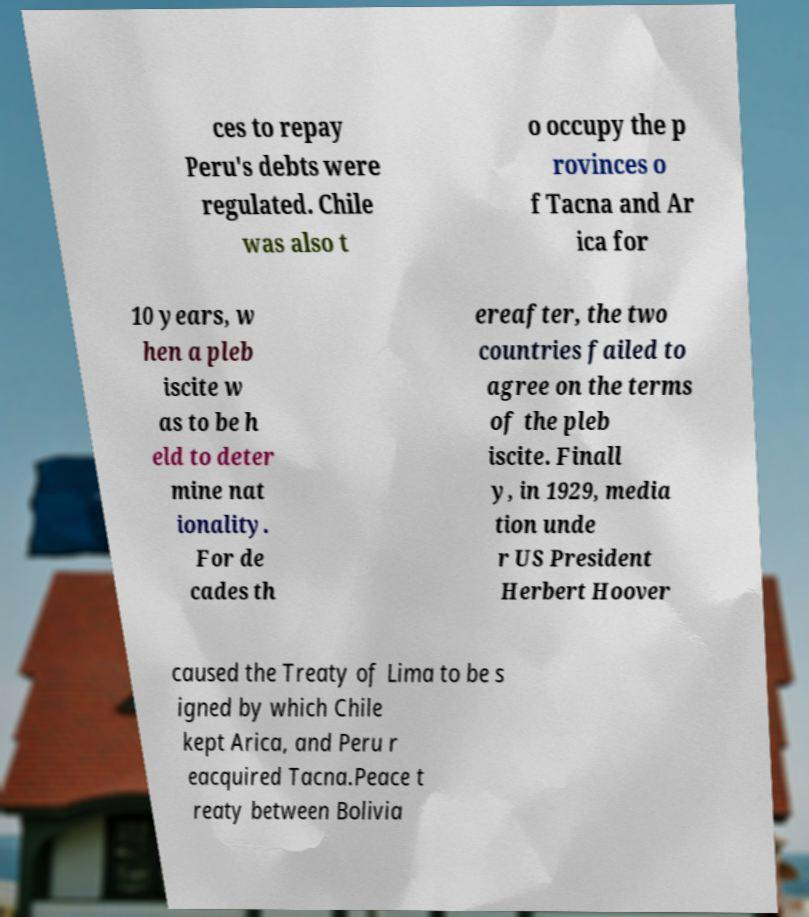Can you read and provide the text displayed in the image?This photo seems to have some interesting text. Can you extract and type it out for me? ces to repay Peru's debts were regulated. Chile was also t o occupy the p rovinces o f Tacna and Ar ica for 10 years, w hen a pleb iscite w as to be h eld to deter mine nat ionality. For de cades th ereafter, the two countries failed to agree on the terms of the pleb iscite. Finall y, in 1929, media tion unde r US President Herbert Hoover caused the Treaty of Lima to be s igned by which Chile kept Arica, and Peru r eacquired Tacna.Peace t reaty between Bolivia 